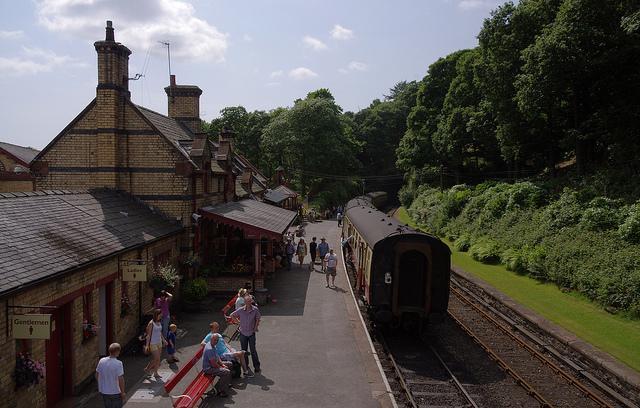How many houses are there?
Give a very brief answer. 0. How many horses in this photo?
Give a very brief answer. 0. 